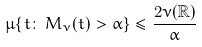<formula> <loc_0><loc_0><loc_500><loc_500>\mu \{ t \colon \, M _ { \nu } ( t ) > \alpha \} \leq \frac { 2 \nu ( \mathbb { R } ) } { \alpha }</formula> 